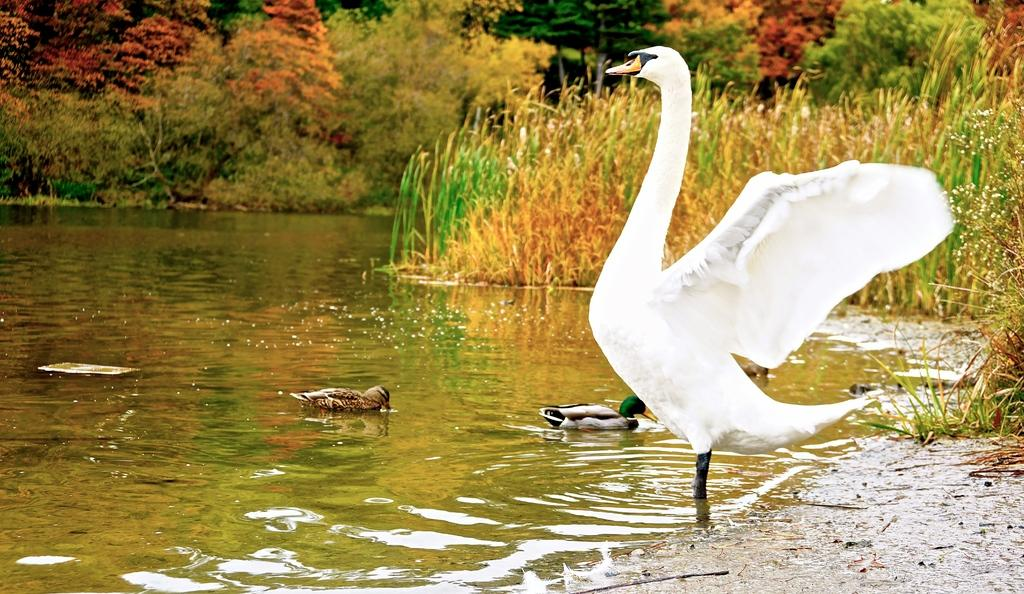What type of animals can be seen in the image? Birds can be seen in the image. What is the primary element in which the birds are situated? The birds are situated in water. What type of vegetation is visible in the image? There is grass in the image. What can be seen in the background of the image? There are trees in the background of the image. What type of prose is being recited by the birds in the image? There is no indication in the image that the birds are reciting any prose, as birds do not have the ability to speak or recite literature. 